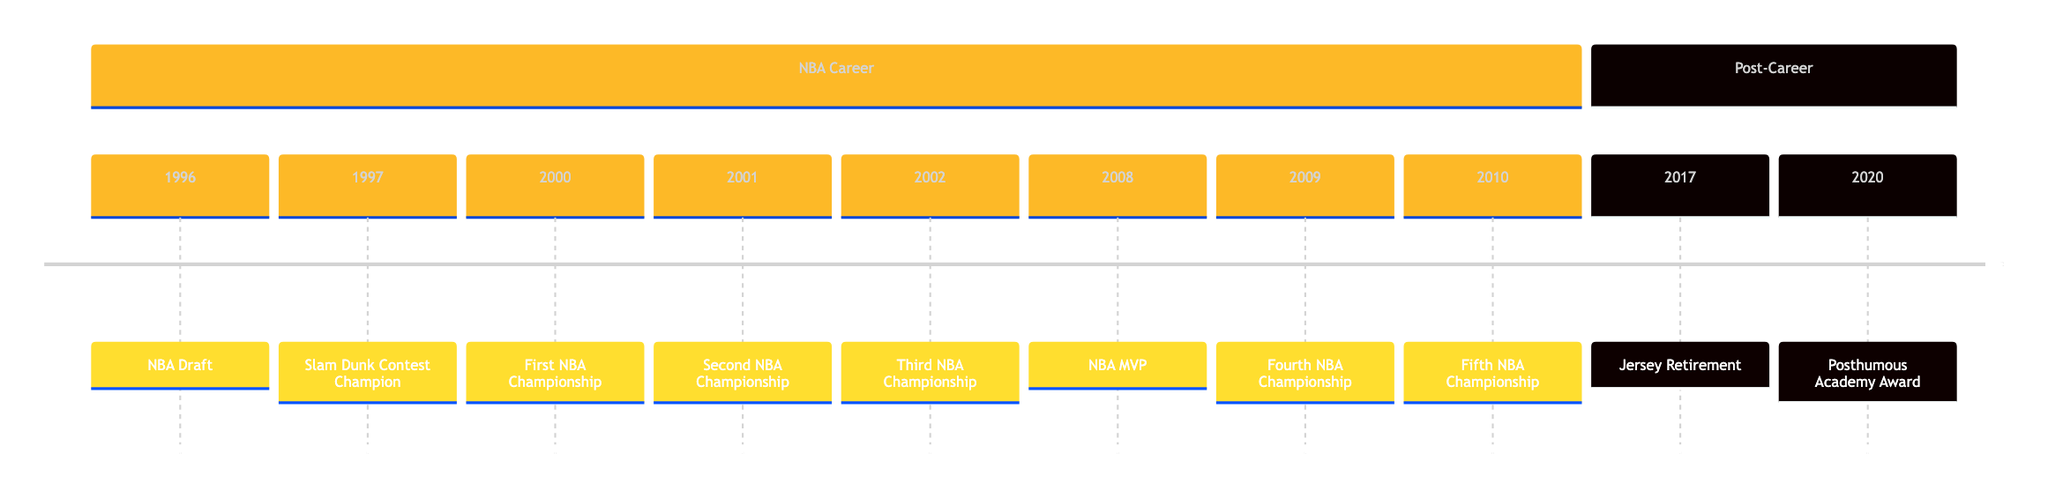What year was Kobe drafted? The timeline indicates that Kobe Bryant was selected in the NBA Draft in 1996, which is the first event listed.
Answer: 1996 How many NBA Championships did Kobe win? By reviewing the timeline, Kobe secured a total of five NBA Championships, as evidenced by the three championship wins from 2000 to 2002 and two additional wins in 2009 and 2010.
Answer: 5 What was Kobe's MVP year? The timeline shows that Kobe was named NBA MVP for the 2007-2008 season, which is specifically highlighted in the year 2008 on the timeline.
Answer: 2008 What notable event occurred in 2017? The timeline highlights that in 2017, Kobe's jersey retirement took place, an important milestone commemorating his career achievements with the Lakers.
Answer: Jersey Retirement Which achievement is associated with the year 2020? The timeline clearly lists that in 2020, Kobe won a posthumous Academy Award for his animated short film "Dear Basketball," marking a significant achievement post-career.
Answer: Posthumous Academy Award In which section does Kobe's MVP achievement appear? Looking at the structure of the timeline, the MVP achievement in 2008 is categorized under the "NBA Career" section, which includes all main career accomplishments.
Answer: NBA Career How many total achievements are mentioned in the timeline? The chronological layout of the timeline displays a total of ten highlighted achievements, combining both his NBA career and post-career accomplishments.
Answer: 10 What graphic is associated with Kobe's Slam Dunk Contest win? The timeline specifies that the graphic associated with the 1997 Slam Dunk Contest victory is labeled as "image/kobe_slamdunk.png," depicting this moment visually.
Answer: image/kobe_slamdunk.png What typography style is used for the MVP achievement? For the year 2008 where the MVP achievement is noted, the typography style is described as "highlight," indicating a special emphasis on this accolade.
Answer: highlight 